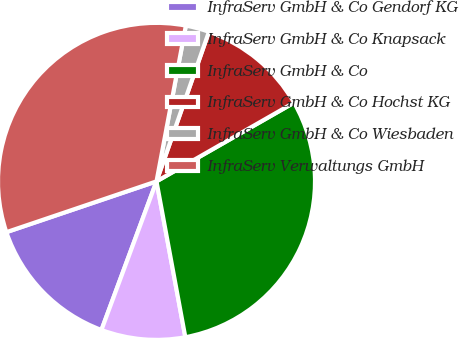Convert chart. <chart><loc_0><loc_0><loc_500><loc_500><pie_chart><fcel>InfraServ GmbH & Co Gendorf KG<fcel>InfraServ GmbH & Co Knapsack<fcel>InfraServ GmbH & Co<fcel>InfraServ GmbH & Co Hochst KG<fcel>InfraServ GmbH & Co Wiesbaden<fcel>InfraServ Verwaltungs GmbH<nl><fcel>14.16%<fcel>8.56%<fcel>30.36%<fcel>11.36%<fcel>2.4%<fcel>33.16%<nl></chart> 